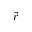Convert formula to latex. <formula><loc_0><loc_0><loc_500><loc_500>\vec { r }</formula> 